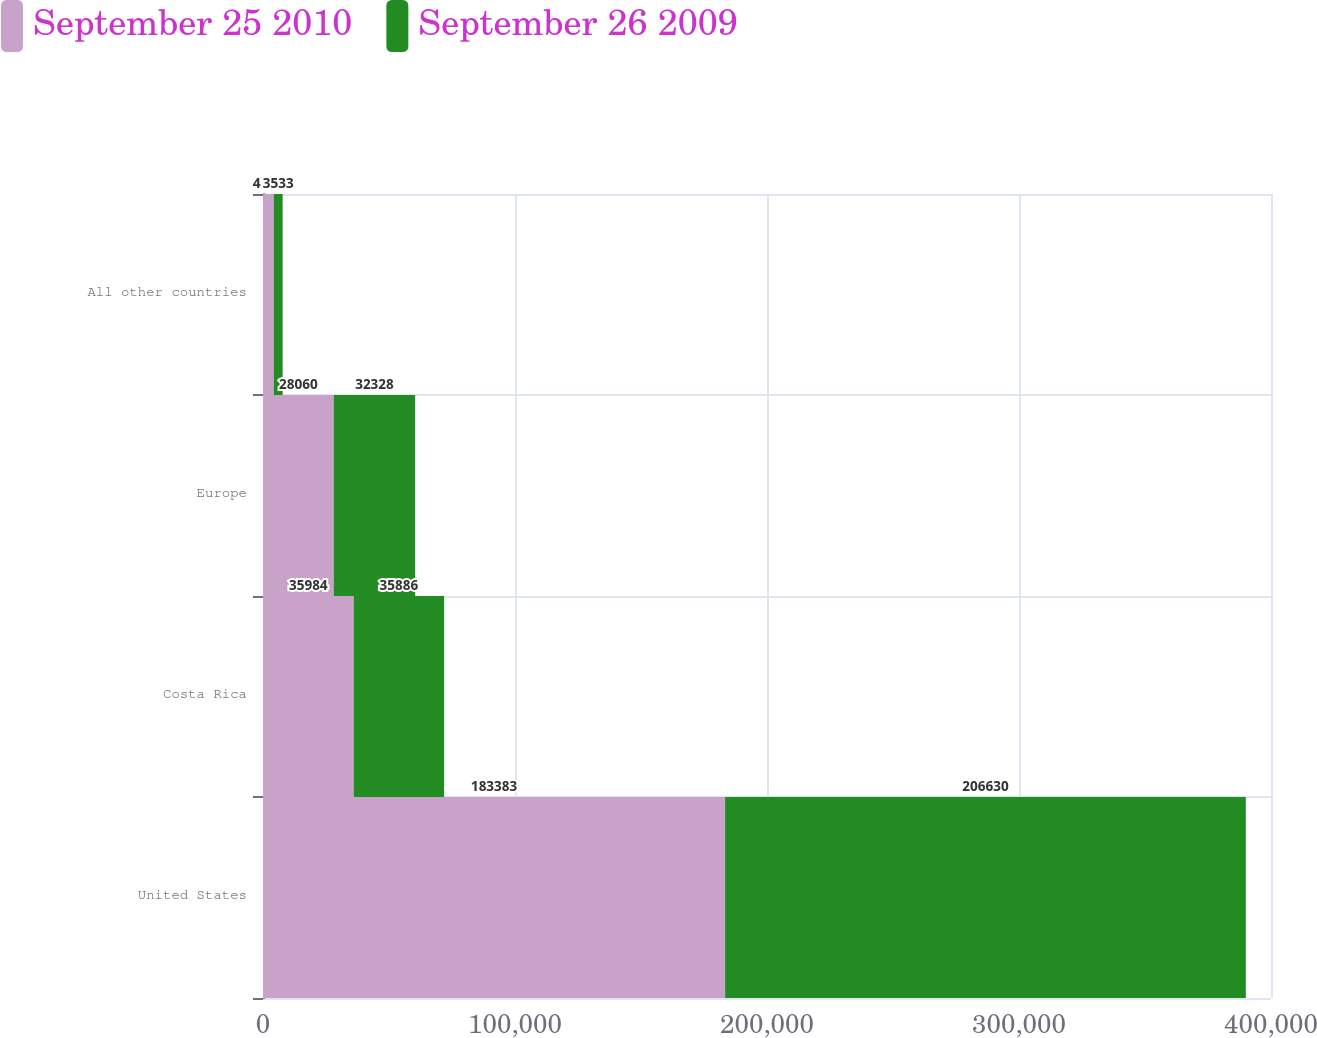Convert chart. <chart><loc_0><loc_0><loc_500><loc_500><stacked_bar_chart><ecel><fcel>United States<fcel>Costa Rica<fcel>Europe<fcel>All other countries<nl><fcel>September 25 2010<fcel>183383<fcel>35984<fcel>28060<fcel>4271<nl><fcel>September 26 2009<fcel>206630<fcel>35886<fcel>32328<fcel>3533<nl></chart> 